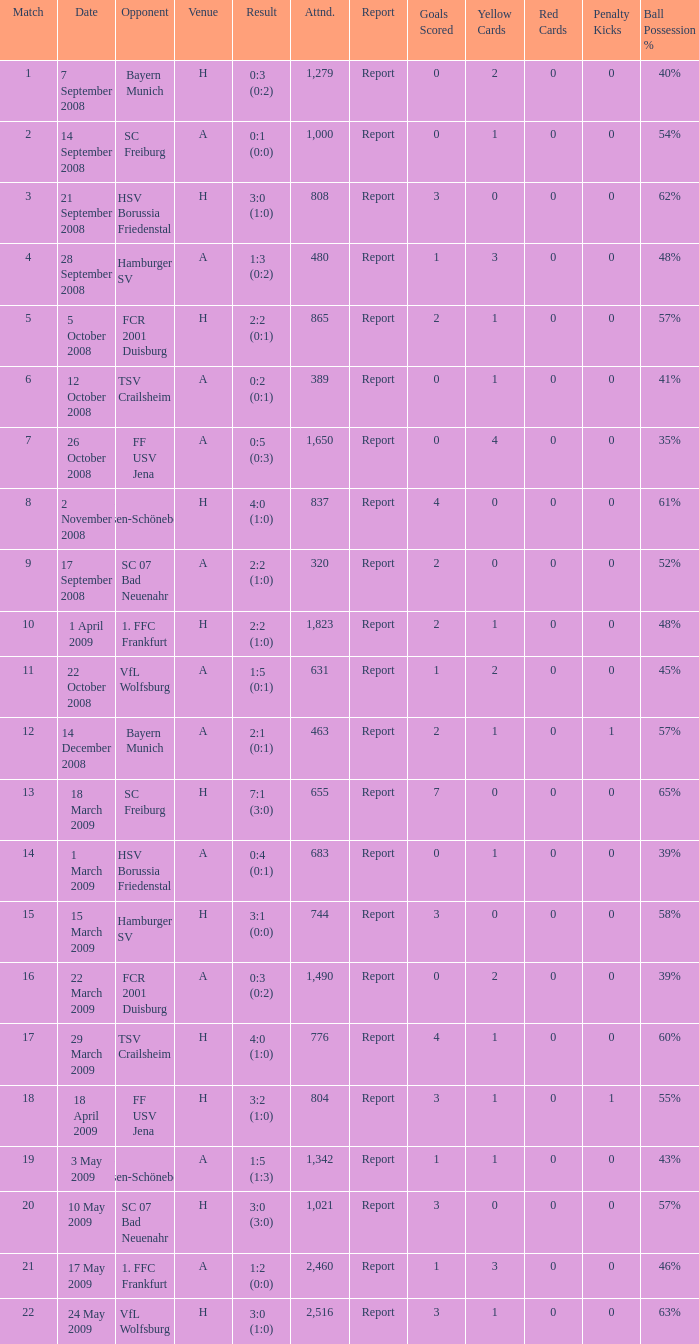In which match number did the outcome end up being 0:5 (0:3)? 1.0. 